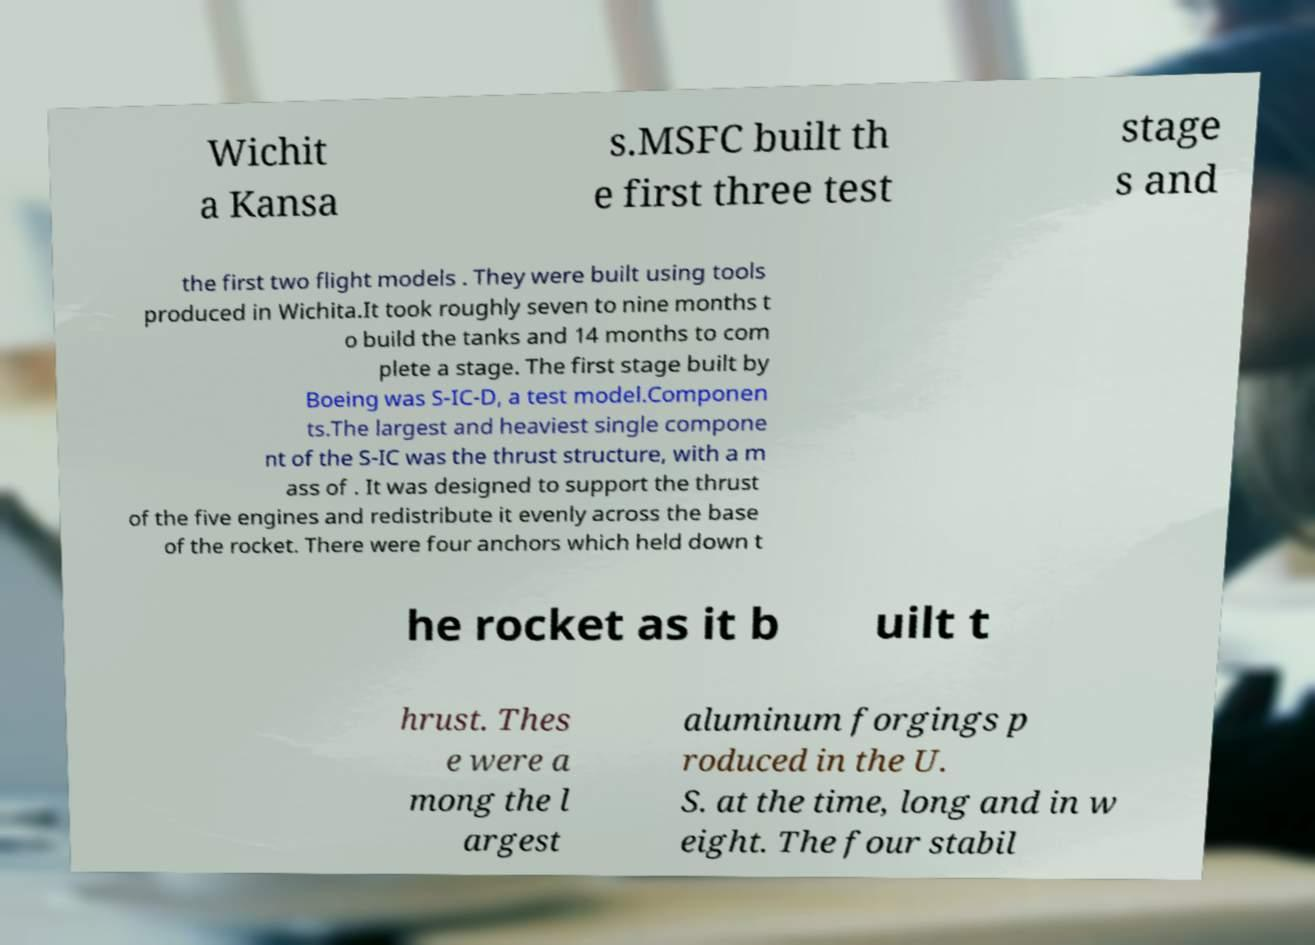There's text embedded in this image that I need extracted. Can you transcribe it verbatim? Wichit a Kansa s.MSFC built th e first three test stage s and the first two flight models . They were built using tools produced in Wichita.It took roughly seven to nine months t o build the tanks and 14 months to com plete a stage. The first stage built by Boeing was S-IC-D, a test model.Componen ts.The largest and heaviest single compone nt of the S-IC was the thrust structure, with a m ass of . It was designed to support the thrust of the five engines and redistribute it evenly across the base of the rocket. There were four anchors which held down t he rocket as it b uilt t hrust. Thes e were a mong the l argest aluminum forgings p roduced in the U. S. at the time, long and in w eight. The four stabil 